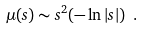<formula> <loc_0><loc_0><loc_500><loc_500>\mu ( s ) \sim s ^ { 2 } ( - \ln | s | ) \ .</formula> 